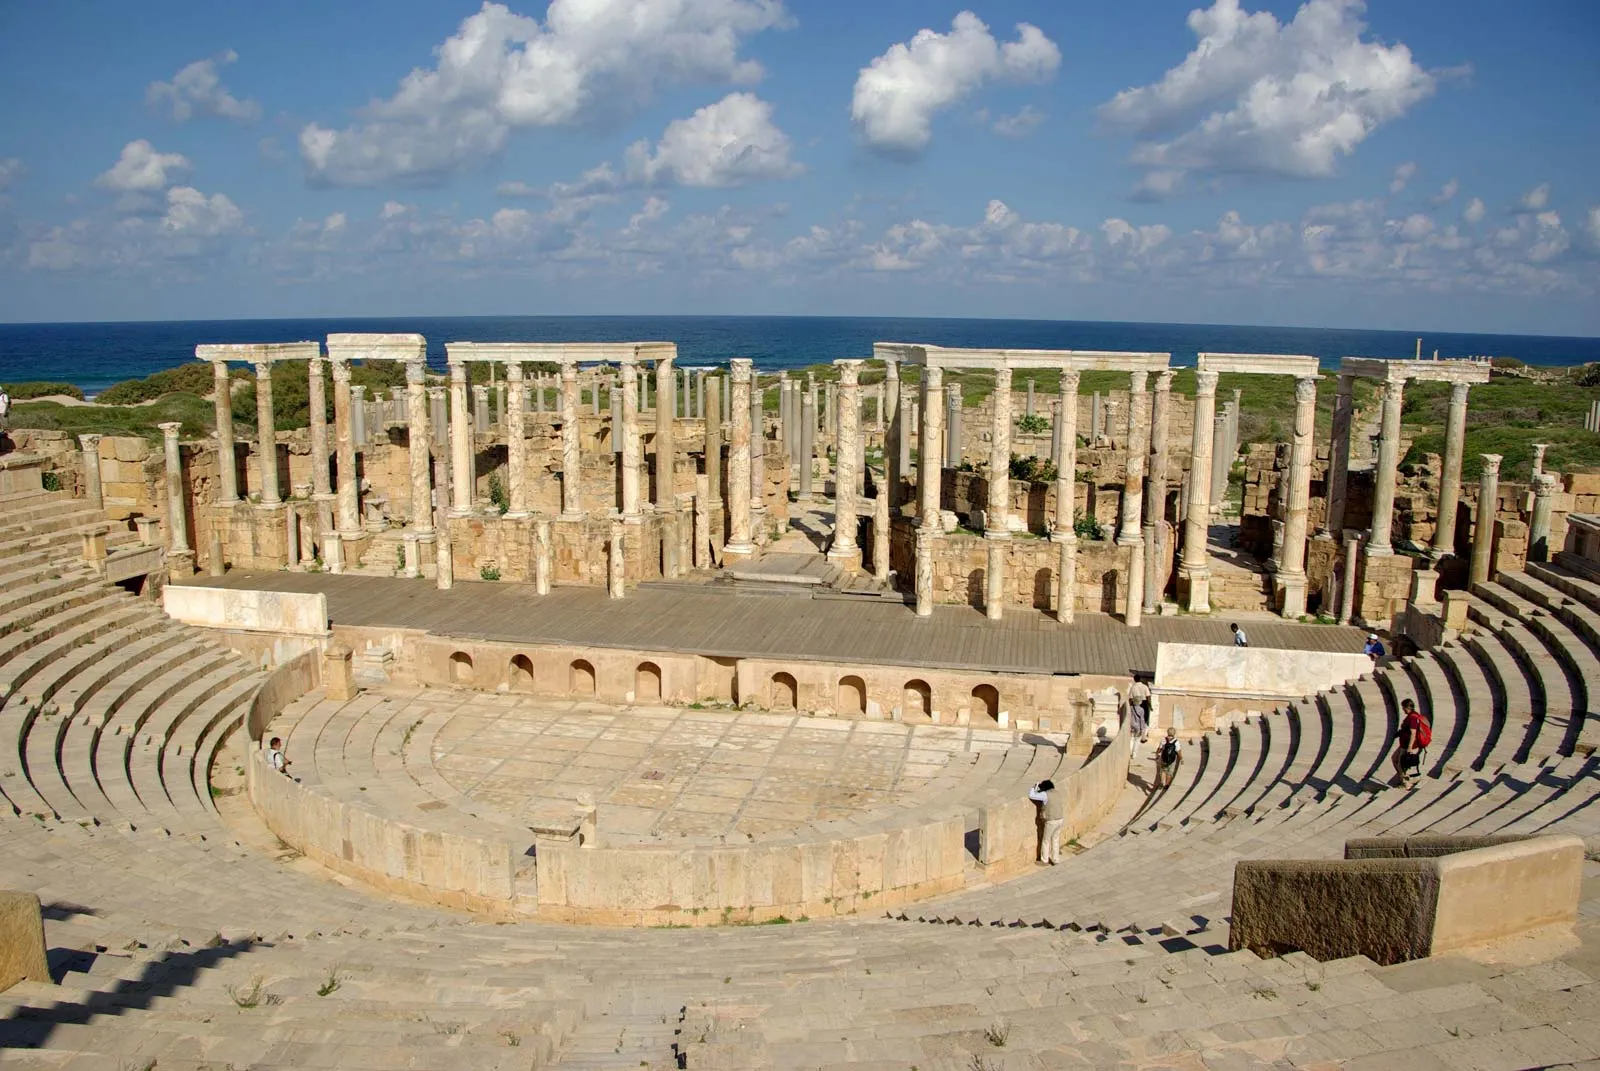If these ruins could talk, what stories do you think they'd tell? If these ancient stones could speak, they would share awe-inspiring tales of a flourishing civilization. They would recount the voices of crowds cheering for triumphant gladiators and the echo of actors' speeches in grand theatrical performances. Stories of illustrious leaders and emperors passing decrees, of bustling markets filled with exotic goods, and of whispers of political intrigue would unfold. They'd describe times of prosperity and moments of despair, the site's transition through various conquests and its resilience through the centuries. Every column and arch would chronicle centuries of human experience, offering a living history of cultural evolution, societal norms, and the unyielding spirit of the people who once called Leptis Magna their home. What if the spirits of ancient Roman citizens still lingered here? What kind of interactions might they have with modern visitors? Imagine if the spirits of ancient Roman citizens roamed these ruins, watching over modern visitors with curiosity and a hint of nostalgia. They might marvel at the advanced technology and clothing of today, whispering tales of their own lives into the ears of those who stand quietly and listen. Perhaps an ancient architect would point out the structural ingenuity of the amphitheater, while a gladiator spirit might recount the thrill of battle. These spectral inhabitants could serve as ethereal guides, sharing wisdom and stories, bridging the gap between millennia. Modern visitors might feel a shiver down their spine or catch a fleeting glimpse of a toga-clad figure out of the corner of their eye, a momentary connection with the past, highlighting the unbroken continuum of human existence. 